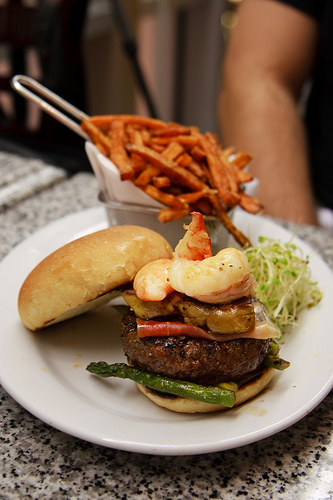<image>
Is there a fries on the plate? Yes. Looking at the image, I can see the fries is positioned on top of the plate, with the plate providing support. Is there a asparagus under the seafood? Yes. The asparagus is positioned underneath the seafood, with the seafood above it in the vertical space. Where is the burger in relation to the fries? Is it under the fries? No. The burger is not positioned under the fries. The vertical relationship between these objects is different. 